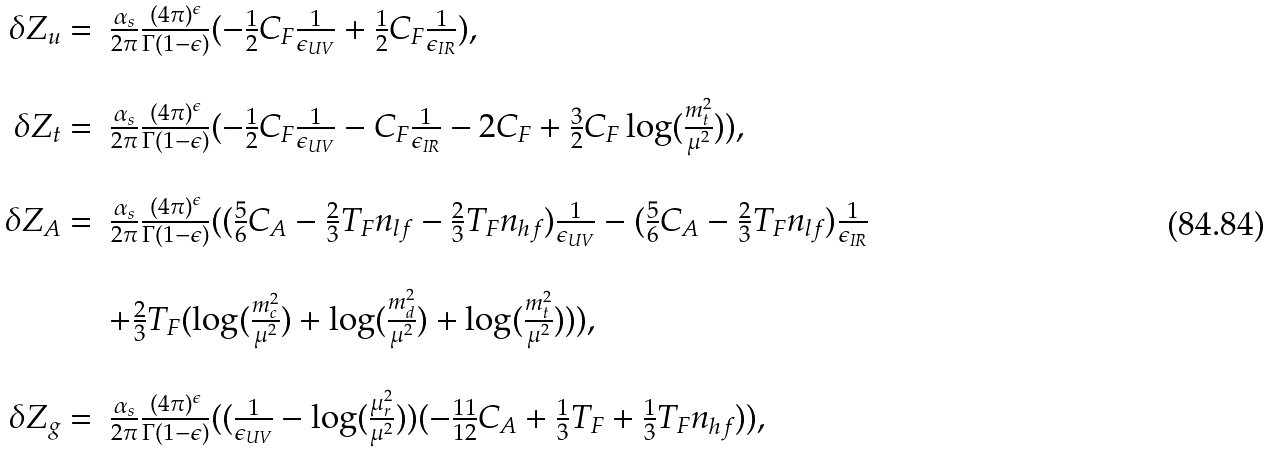Convert formula to latex. <formula><loc_0><loc_0><loc_500><loc_500>\begin{array} { r l } \delta Z _ { u } = & \frac { \alpha _ { s } } { 2 \pi } \frac { ( 4 \pi ) ^ { \epsilon } } { \Gamma ( 1 - \epsilon ) } ( - \frac { 1 } { 2 } C _ { F } \frac { 1 } { \epsilon _ { U V } } + \frac { 1 } { 2 } C _ { F } \frac { 1 } { \epsilon _ { I R } } ) , \\ \\ \delta Z _ { t } = & \frac { \alpha _ { s } } { 2 \pi } \frac { ( 4 \pi ) ^ { \epsilon } } { \Gamma ( 1 - \epsilon ) } ( - \frac { 1 } { 2 } C _ { F } \frac { 1 } { \epsilon _ { U V } } - C _ { F } \frac { 1 } { \epsilon _ { I R } } - 2 C _ { F } + \frac { 3 } { 2 } C _ { F } \log ( \frac { m _ { t } ^ { 2 } } { \mu ^ { 2 } } ) ) , \\ \\ \delta Z _ { A } = & \frac { \alpha _ { s } } { 2 \pi } \frac { ( 4 \pi ) ^ { \epsilon } } { \Gamma ( 1 - \epsilon ) } ( ( \frac { 5 } { 6 } C _ { A } - \frac { 2 } { 3 } T _ { F } n _ { l f } - \frac { 2 } { 3 } T _ { F } n _ { h f } ) \frac { 1 } { \epsilon _ { U V } } - ( \frac { 5 } { 6 } C _ { A } - \frac { 2 } { 3 } T _ { F } n _ { l f } ) \frac { 1 } { \epsilon _ { I R } } \\ \\ & + \frac { 2 } { 3 } T _ { F } ( \log ( \frac { m _ { c } ^ { 2 } } { \mu ^ { 2 } } ) + \log ( \frac { m _ { d } ^ { 2 } } { \mu ^ { 2 } } ) + \log ( \frac { m _ { t } ^ { 2 } } { \mu ^ { 2 } } ) ) ) , \\ \\ \delta Z _ { g } = & \frac { \alpha _ { s } } { 2 \pi } \frac { ( 4 \pi ) ^ { \epsilon } } { \Gamma ( 1 - \epsilon ) } ( ( \frac { 1 } { \epsilon _ { U V } } - \log ( \frac { \mu _ { r } ^ { 2 } } { \mu ^ { 2 } } ) ) ( - \frac { 1 1 } { 1 2 } C _ { A } + \frac { 1 } { 3 } T _ { F } + \frac { 1 } { 3 } T _ { F } n _ { h f } ) ) , \end{array}</formula> 